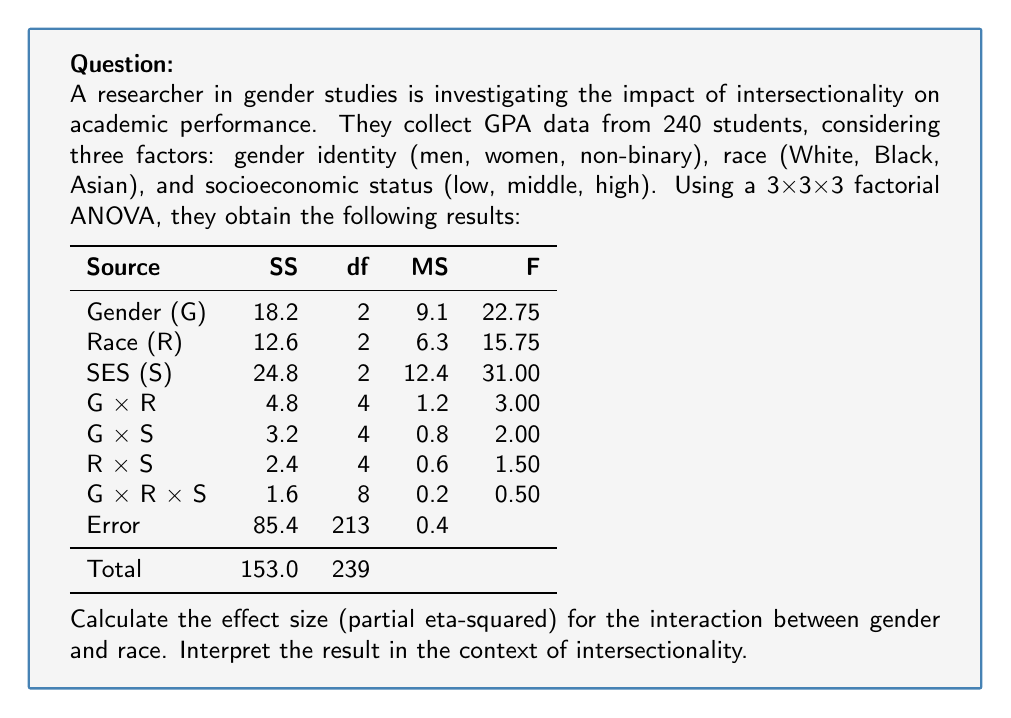Can you solve this math problem? To calculate the partial eta-squared ($\eta_p^2$) for the interaction between gender and race, we'll follow these steps:

1) The formula for partial eta-squared is:

   $$\eta_p^2 = \frac{SS_{\text{effect}}}{SS_{\text{effect}} + SS_{\text{error}}}$$

2) From the ANOVA table, we can see:
   - $SS_{\text{G × R}} = 4.8$ (effect of interest)
   - $SS_{\text{error}} = 85.4$

3) Plugging these values into the formula:

   $$\eta_p^2 = \frac{4.8}{4.8 + 85.4} = \frac{4.8}{90.2} \approx 0.0532$$

4) Convert to a percentage: 0.0532 * 100 ≈ 5.32%

Interpretation:
The partial eta-squared value of 0.0532 indicates that approximately 5.32% of the variance in academic performance (GPA) that is not explained by the main effects of gender and race alone can be accounted for by their interaction. This suggests a small to moderate effect size for the interaction between gender and race.

In the context of intersectionality, this result implies that there is some evidence of intersectional effects between gender and race on academic performance. The interaction explains a modest amount of variance, indicating that the impact of gender on academic performance may differ across racial groups, or vice versa. However, the effect is not large, suggesting that while intersectionality between gender and race does play a role in academic performance, other factors (including the main effects and other interactions) may have stronger influences.

This finding supports the importance of considering intersectional perspectives in academic research, as it demonstrates that the interplay between gender and race contributes to variations in academic outcomes beyond what can be explained by considering these factors independently.
Answer: $\eta_p^2 \approx 0.0532$ (5.32%); small to moderate intersectional effect between gender and race on academic performance. 